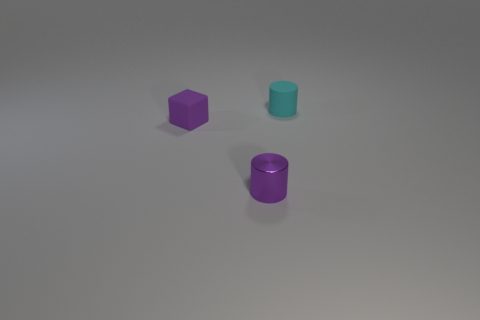What is the size of the object that is both right of the small cube and behind the tiny metallic object?
Provide a succinct answer. Small. What shape is the matte object left of the rubber thing to the right of the tiny metallic cylinder?
Make the answer very short. Cube. Does the metal cylinder have the same color as the small matte object that is left of the purple shiny cylinder?
Offer a very short reply. Yes. There is a small thing that is both in front of the cyan rubber cylinder and behind the small purple cylinder; what is its color?
Ensure brevity in your answer.  Purple. There is a tiny cylinder to the left of the small cyan rubber cylinder; what number of purple metal things are left of it?
Your answer should be very brief. 0. There is a small purple object that is in front of the purple rubber cube; is it the same shape as the small object that is behind the purple rubber cube?
Your answer should be compact. Yes. The cyan object that is the same shape as the small purple metallic thing is what size?
Your answer should be very brief. Small. Is the cyan cylinder made of the same material as the purple cube?
Your answer should be compact. Yes. What is the color of the other object that is the same shape as the small cyan rubber thing?
Your answer should be compact. Purple. Do the small block and the small shiny cylinder have the same color?
Keep it short and to the point. Yes. 